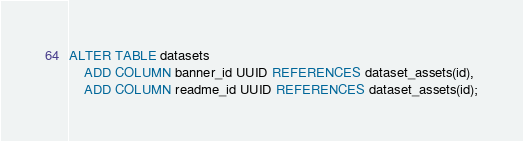<code> <loc_0><loc_0><loc_500><loc_500><_SQL_>ALTER TABLE datasets
    ADD COLUMN banner_id UUID REFERENCES dataset_assets(id),
    ADD COLUMN readme_id UUID REFERENCES dataset_assets(id);
</code> 